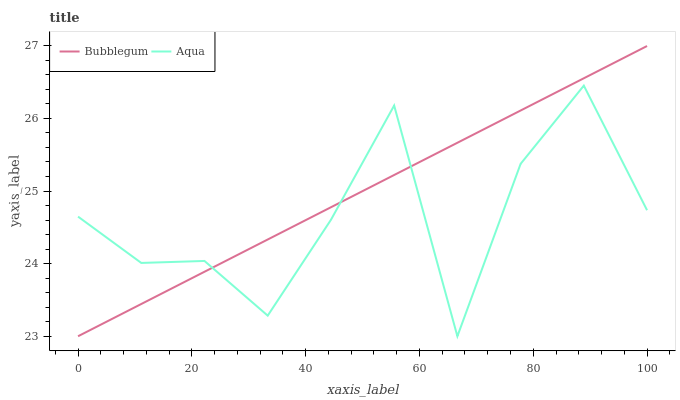Does Aqua have the minimum area under the curve?
Answer yes or no. Yes. Does Bubblegum have the maximum area under the curve?
Answer yes or no. Yes. Does Bubblegum have the minimum area under the curve?
Answer yes or no. No. Is Bubblegum the smoothest?
Answer yes or no. Yes. Is Aqua the roughest?
Answer yes or no. Yes. Is Bubblegum the roughest?
Answer yes or no. No. Does Bubblegum have the highest value?
Answer yes or no. Yes. Does Aqua intersect Bubblegum?
Answer yes or no. Yes. Is Aqua less than Bubblegum?
Answer yes or no. No. Is Aqua greater than Bubblegum?
Answer yes or no. No. 